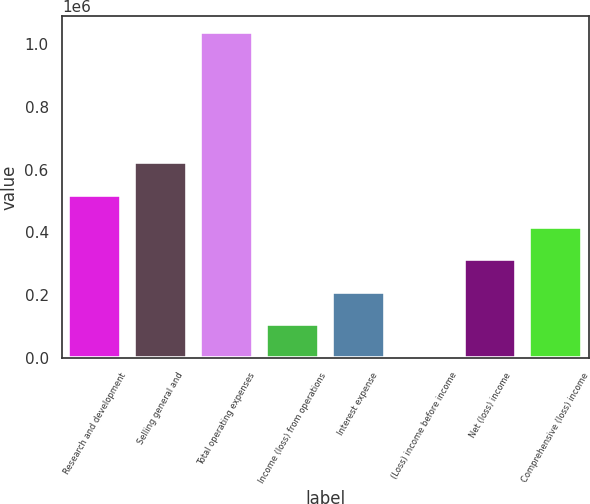Convert chart. <chart><loc_0><loc_0><loc_500><loc_500><bar_chart><fcel>Research and development<fcel>Selling general and<fcel>Total operating expenses<fcel>Income (loss) from operations<fcel>Interest expense<fcel>(Loss) income before income<fcel>Net (loss) income<fcel>Comprehensive (loss) income<nl><fcel>520224<fcel>623696<fcel>1.03758e+06<fcel>106334<fcel>209807<fcel>2862<fcel>313279<fcel>416751<nl></chart> 